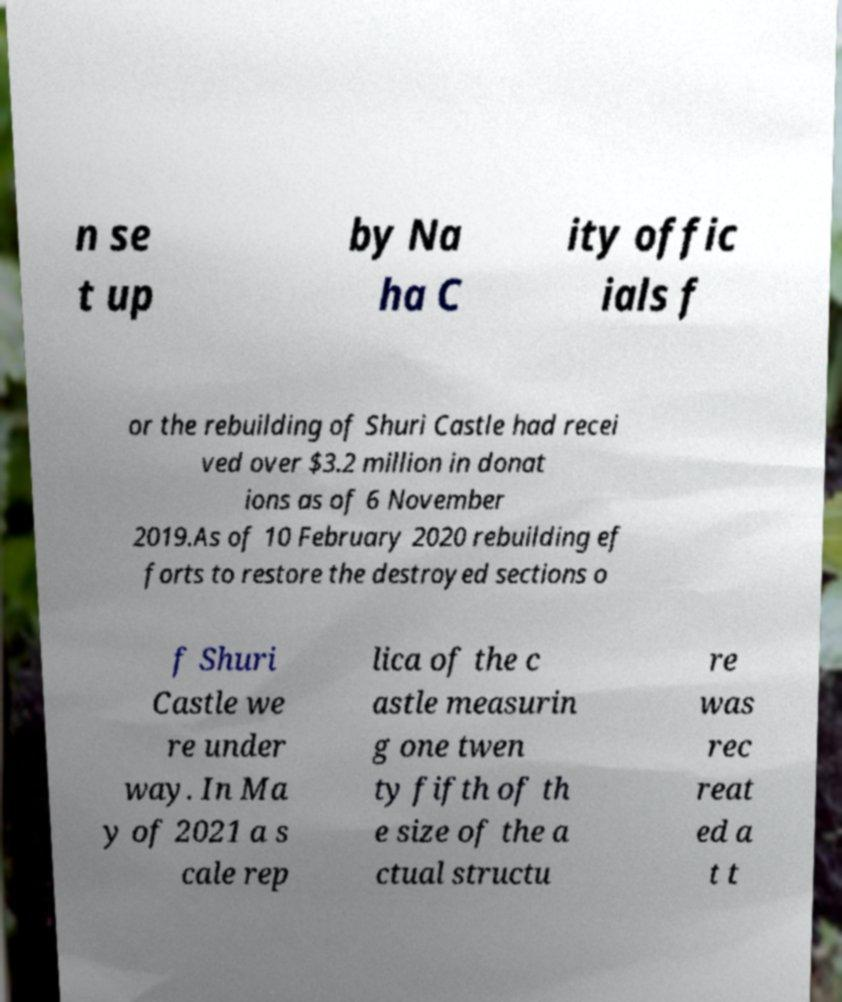For documentation purposes, I need the text within this image transcribed. Could you provide that? n se t up by Na ha C ity offic ials f or the rebuilding of Shuri Castle had recei ved over $3.2 million in donat ions as of 6 November 2019.As of 10 February 2020 rebuilding ef forts to restore the destroyed sections o f Shuri Castle we re under way. In Ma y of 2021 a s cale rep lica of the c astle measurin g one twen ty fifth of th e size of the a ctual structu re was rec reat ed a t t 